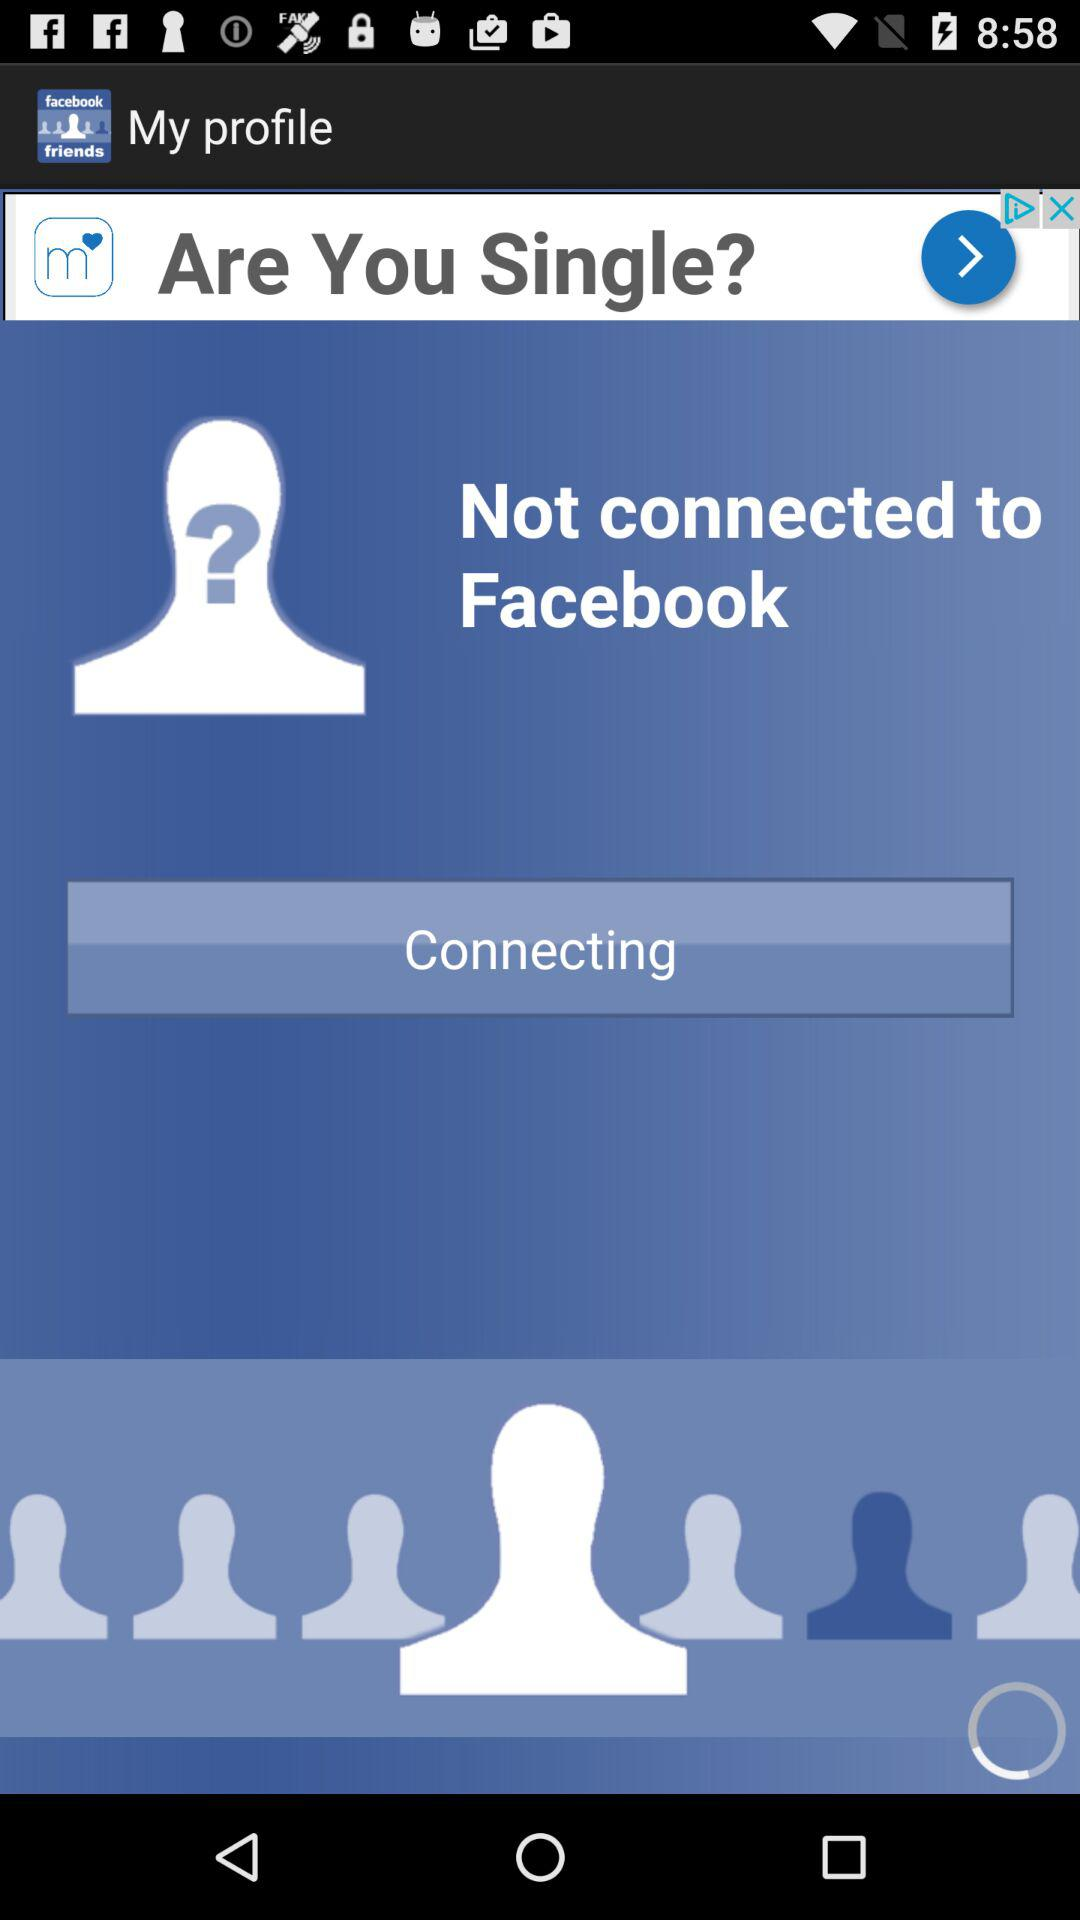Who is connecting to Facebook?
When the provided information is insufficient, respond with <no answer>. <no answer> 